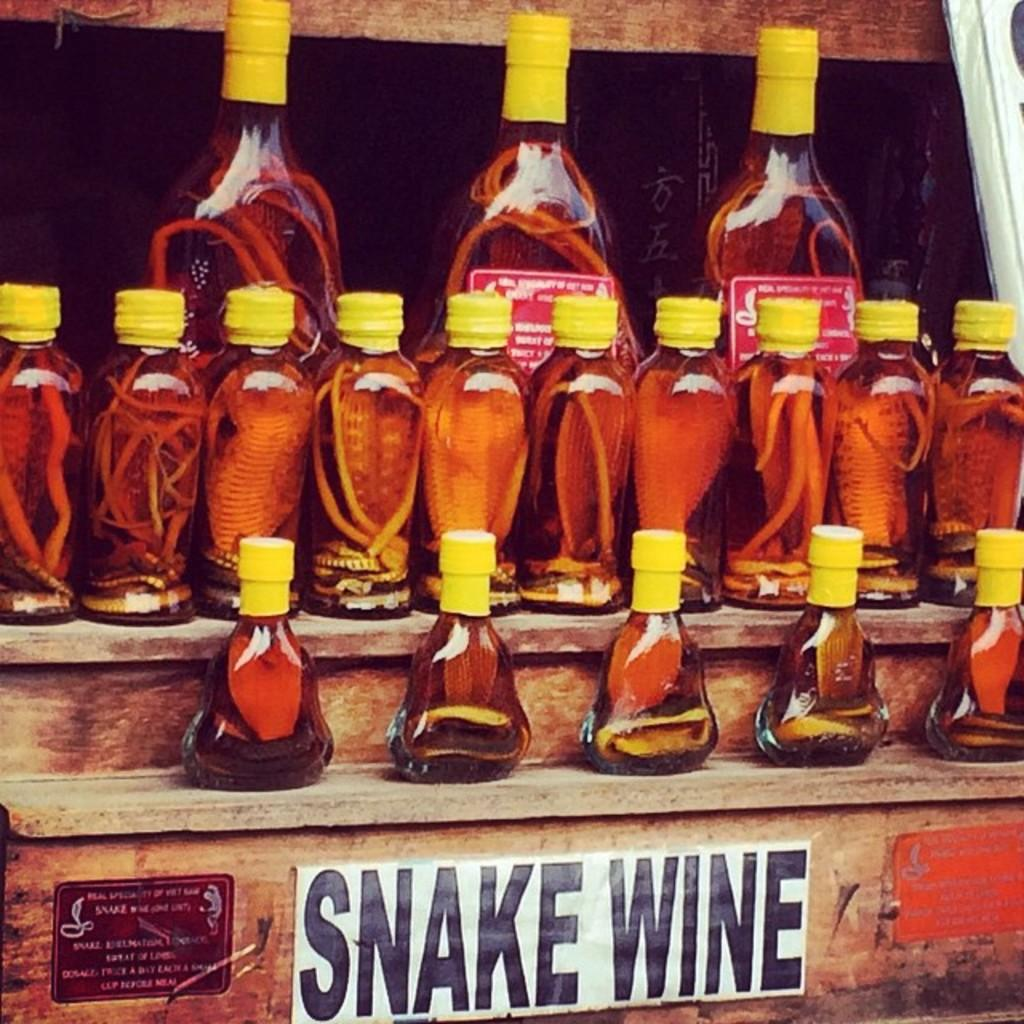What is the main subject of the image? The main subject of the image is a group of bottles. What is inside the bottles? There are snakes inside the bottles. How are the bottles arranged or supported in the image? The bottles are placed on a wooden rack. How do the snakes in the bottles fulfill their desires? The image does not provide information about the desires of the snakes or how they might fulfill them. 